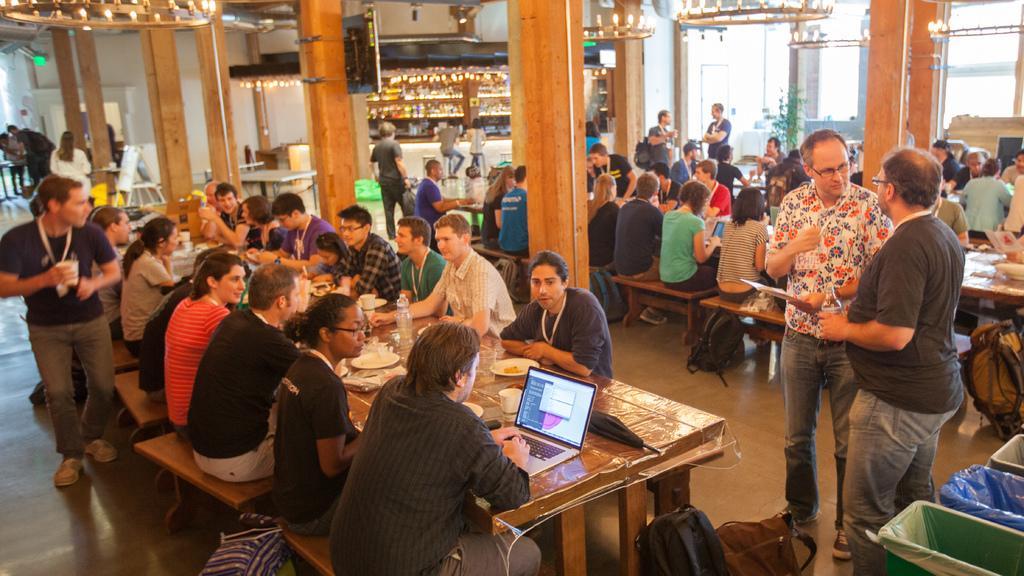How would you summarize this image in a sentence or two? In this picture we can see a group of people where some are sitting on benches and some are standing on the floor and in front of them on tables we can see a laptop, umbrella, plates, cups and in the background we can see pillars, lights. 